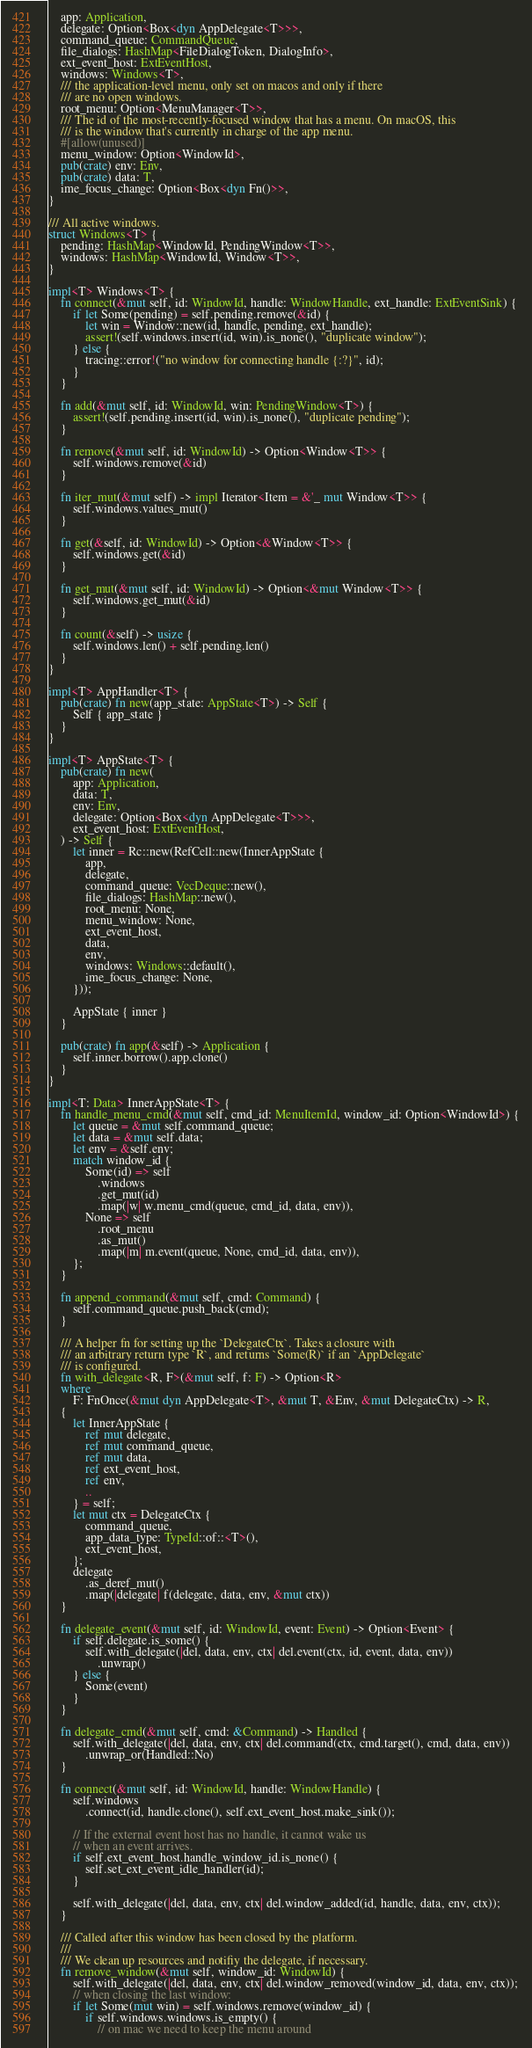<code> <loc_0><loc_0><loc_500><loc_500><_Rust_>    app: Application,
    delegate: Option<Box<dyn AppDelegate<T>>>,
    command_queue: CommandQueue,
    file_dialogs: HashMap<FileDialogToken, DialogInfo>,
    ext_event_host: ExtEventHost,
    windows: Windows<T>,
    /// the application-level menu, only set on macos and only if there
    /// are no open windows.
    root_menu: Option<MenuManager<T>>,
    /// The id of the most-recently-focused window that has a menu. On macOS, this
    /// is the window that's currently in charge of the app menu.
    #[allow(unused)]
    menu_window: Option<WindowId>,
    pub(crate) env: Env,
    pub(crate) data: T,
    ime_focus_change: Option<Box<dyn Fn()>>,
}

/// All active windows.
struct Windows<T> {
    pending: HashMap<WindowId, PendingWindow<T>>,
    windows: HashMap<WindowId, Window<T>>,
}

impl<T> Windows<T> {
    fn connect(&mut self, id: WindowId, handle: WindowHandle, ext_handle: ExtEventSink) {
        if let Some(pending) = self.pending.remove(&id) {
            let win = Window::new(id, handle, pending, ext_handle);
            assert!(self.windows.insert(id, win).is_none(), "duplicate window");
        } else {
            tracing::error!("no window for connecting handle {:?}", id);
        }
    }

    fn add(&mut self, id: WindowId, win: PendingWindow<T>) {
        assert!(self.pending.insert(id, win).is_none(), "duplicate pending");
    }

    fn remove(&mut self, id: WindowId) -> Option<Window<T>> {
        self.windows.remove(&id)
    }

    fn iter_mut(&mut self) -> impl Iterator<Item = &'_ mut Window<T>> {
        self.windows.values_mut()
    }

    fn get(&self, id: WindowId) -> Option<&Window<T>> {
        self.windows.get(&id)
    }

    fn get_mut(&mut self, id: WindowId) -> Option<&mut Window<T>> {
        self.windows.get_mut(&id)
    }

    fn count(&self) -> usize {
        self.windows.len() + self.pending.len()
    }
}

impl<T> AppHandler<T> {
    pub(crate) fn new(app_state: AppState<T>) -> Self {
        Self { app_state }
    }
}

impl<T> AppState<T> {
    pub(crate) fn new(
        app: Application,
        data: T,
        env: Env,
        delegate: Option<Box<dyn AppDelegate<T>>>,
        ext_event_host: ExtEventHost,
    ) -> Self {
        let inner = Rc::new(RefCell::new(InnerAppState {
            app,
            delegate,
            command_queue: VecDeque::new(),
            file_dialogs: HashMap::new(),
            root_menu: None,
            menu_window: None,
            ext_event_host,
            data,
            env,
            windows: Windows::default(),
            ime_focus_change: None,
        }));

        AppState { inner }
    }

    pub(crate) fn app(&self) -> Application {
        self.inner.borrow().app.clone()
    }
}

impl<T: Data> InnerAppState<T> {
    fn handle_menu_cmd(&mut self, cmd_id: MenuItemId, window_id: Option<WindowId>) {
        let queue = &mut self.command_queue;
        let data = &mut self.data;
        let env = &self.env;
        match window_id {
            Some(id) => self
                .windows
                .get_mut(id)
                .map(|w| w.menu_cmd(queue, cmd_id, data, env)),
            None => self
                .root_menu
                .as_mut()
                .map(|m| m.event(queue, None, cmd_id, data, env)),
        };
    }

    fn append_command(&mut self, cmd: Command) {
        self.command_queue.push_back(cmd);
    }

    /// A helper fn for setting up the `DelegateCtx`. Takes a closure with
    /// an arbitrary return type `R`, and returns `Some(R)` if an `AppDelegate`
    /// is configured.
    fn with_delegate<R, F>(&mut self, f: F) -> Option<R>
    where
        F: FnOnce(&mut dyn AppDelegate<T>, &mut T, &Env, &mut DelegateCtx) -> R,
    {
        let InnerAppState {
            ref mut delegate,
            ref mut command_queue,
            ref mut data,
            ref ext_event_host,
            ref env,
            ..
        } = self;
        let mut ctx = DelegateCtx {
            command_queue,
            app_data_type: TypeId::of::<T>(),
            ext_event_host,
        };
        delegate
            .as_deref_mut()
            .map(|delegate| f(delegate, data, env, &mut ctx))
    }

    fn delegate_event(&mut self, id: WindowId, event: Event) -> Option<Event> {
        if self.delegate.is_some() {
            self.with_delegate(|del, data, env, ctx| del.event(ctx, id, event, data, env))
                .unwrap()
        } else {
            Some(event)
        }
    }

    fn delegate_cmd(&mut self, cmd: &Command) -> Handled {
        self.with_delegate(|del, data, env, ctx| del.command(ctx, cmd.target(), cmd, data, env))
            .unwrap_or(Handled::No)
    }

    fn connect(&mut self, id: WindowId, handle: WindowHandle) {
        self.windows
            .connect(id, handle.clone(), self.ext_event_host.make_sink());

        // If the external event host has no handle, it cannot wake us
        // when an event arrives.
        if self.ext_event_host.handle_window_id.is_none() {
            self.set_ext_event_idle_handler(id);
        }

        self.with_delegate(|del, data, env, ctx| del.window_added(id, handle, data, env, ctx));
    }

    /// Called after this window has been closed by the platform.
    ///
    /// We clean up resources and notifiy the delegate, if necessary.
    fn remove_window(&mut self, window_id: WindowId) {
        self.with_delegate(|del, data, env, ctx| del.window_removed(window_id, data, env, ctx));
        // when closing the last window:
        if let Some(mut win) = self.windows.remove(window_id) {
            if self.windows.windows.is_empty() {
                // on mac we need to keep the menu around</code> 